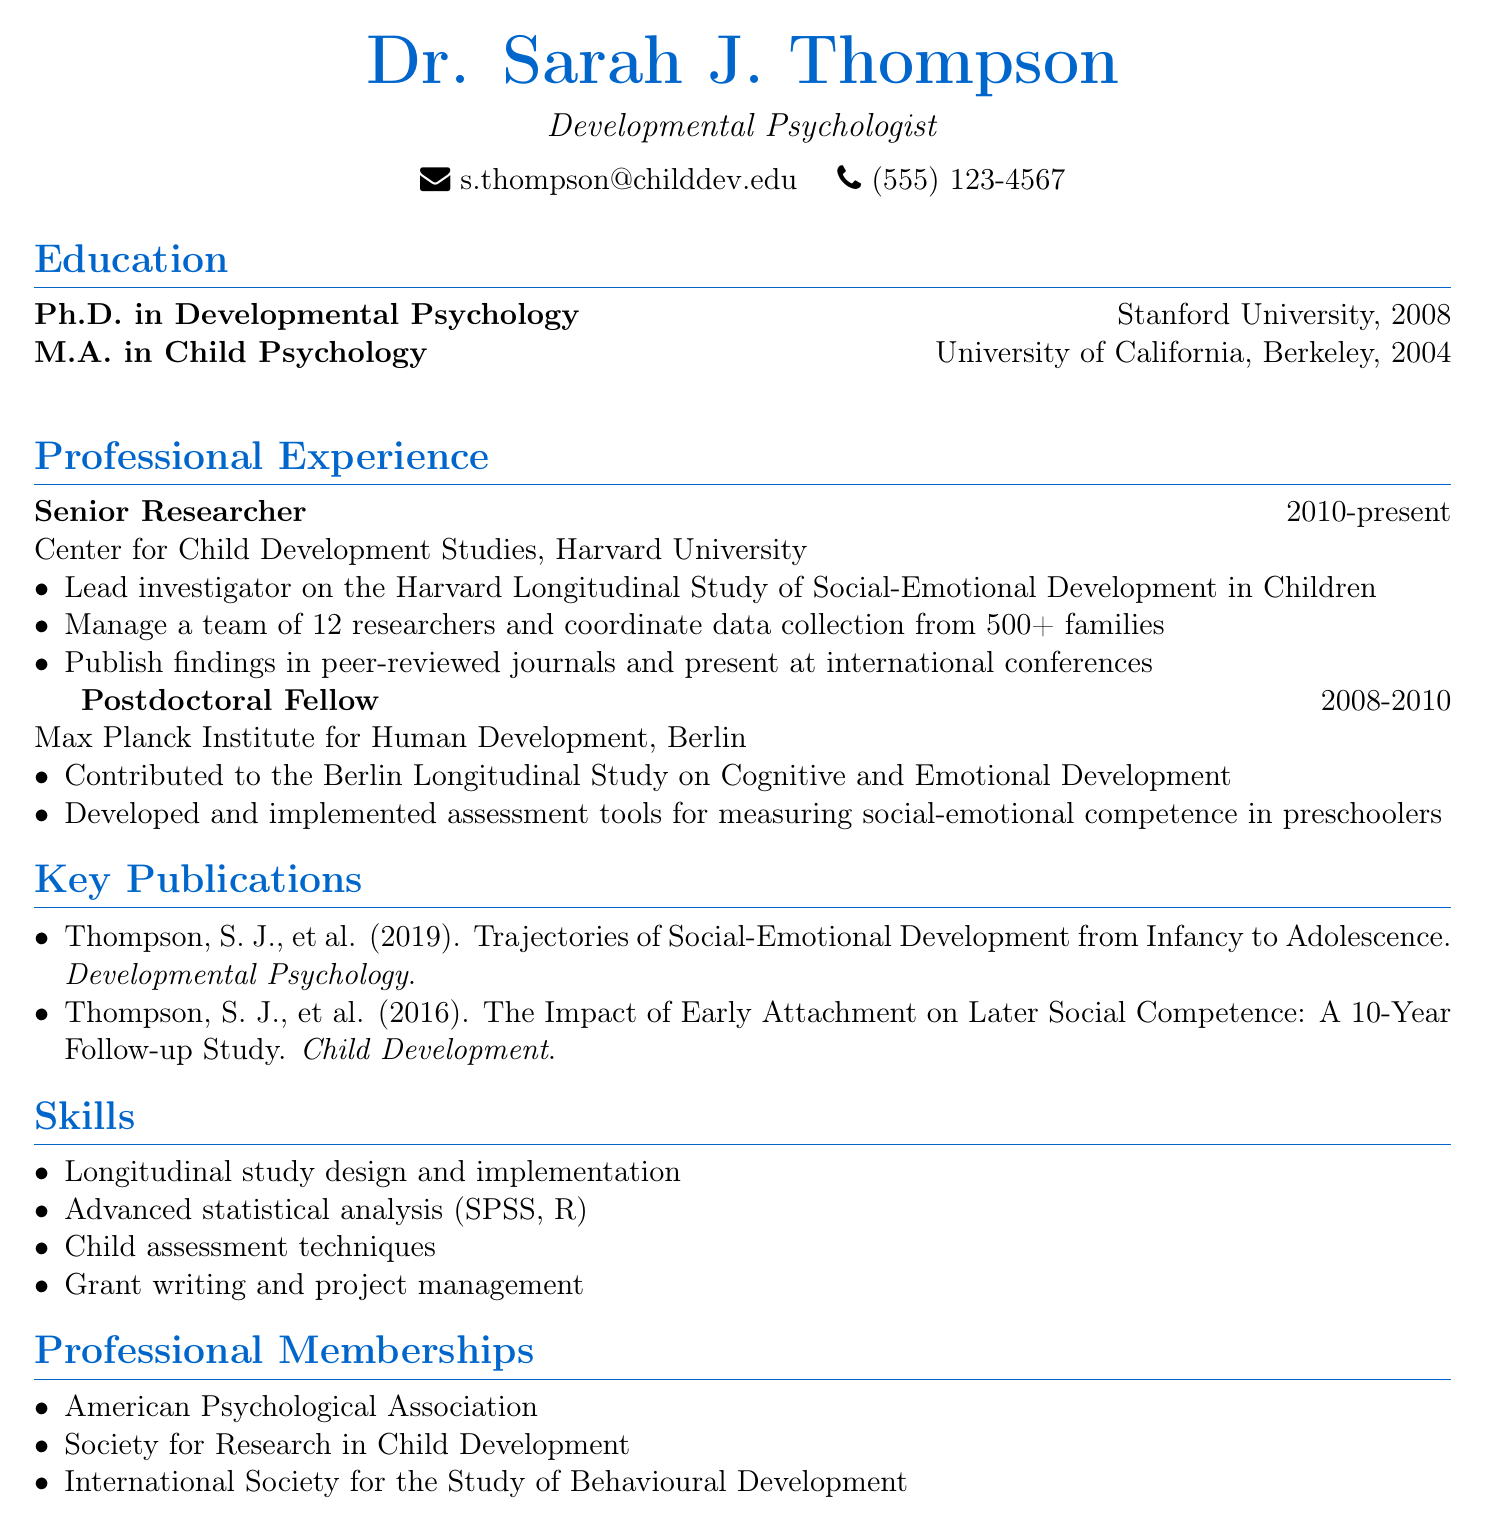What is the name of the researcher? The name of the researcher is listed at the top of the document.
Answer: Dr. Sarah J. Thompson What is the highest degree obtained by Dr. Thompson? The highest degree is mentioned under the education section.
Answer: Ph.D. in Developmental Psychology Which university did Dr. Thompson earn her Master's degree from? The master's degree institution is listed in the education section of the document.
Answer: University of California, Berkeley What is the title of the key publication from 2019? The publication title is found in the key publications section.
Answer: Trajectories of Social-Emotional Development from Infancy to Adolescence How long has Dr. Thompson been a Senior Researcher? This can be calculated from the duration listed under professional experience.
Answer: 13 years What is the total number of researchers managed by Dr. Thompson in her current role? The number is explicitly stated in the responsibilities section of her professional experience.
Answer: 12 researchers What type of analysis skills does Dr. Thompson possess? The skills section lists specific skills related to her expertise.
Answer: Advanced statistical analysis In which professional organization is Dr. Thompson a member? Professional memberships are listed towards the end of the document.
Answer: American Psychological Association Where did Dr. Thompson complete her postdoctoral fellowship? The institution for her postdoctoral fellowship is mentioned in the professional experience section.
Answer: Max Planck Institute for Human Development, Berlin 